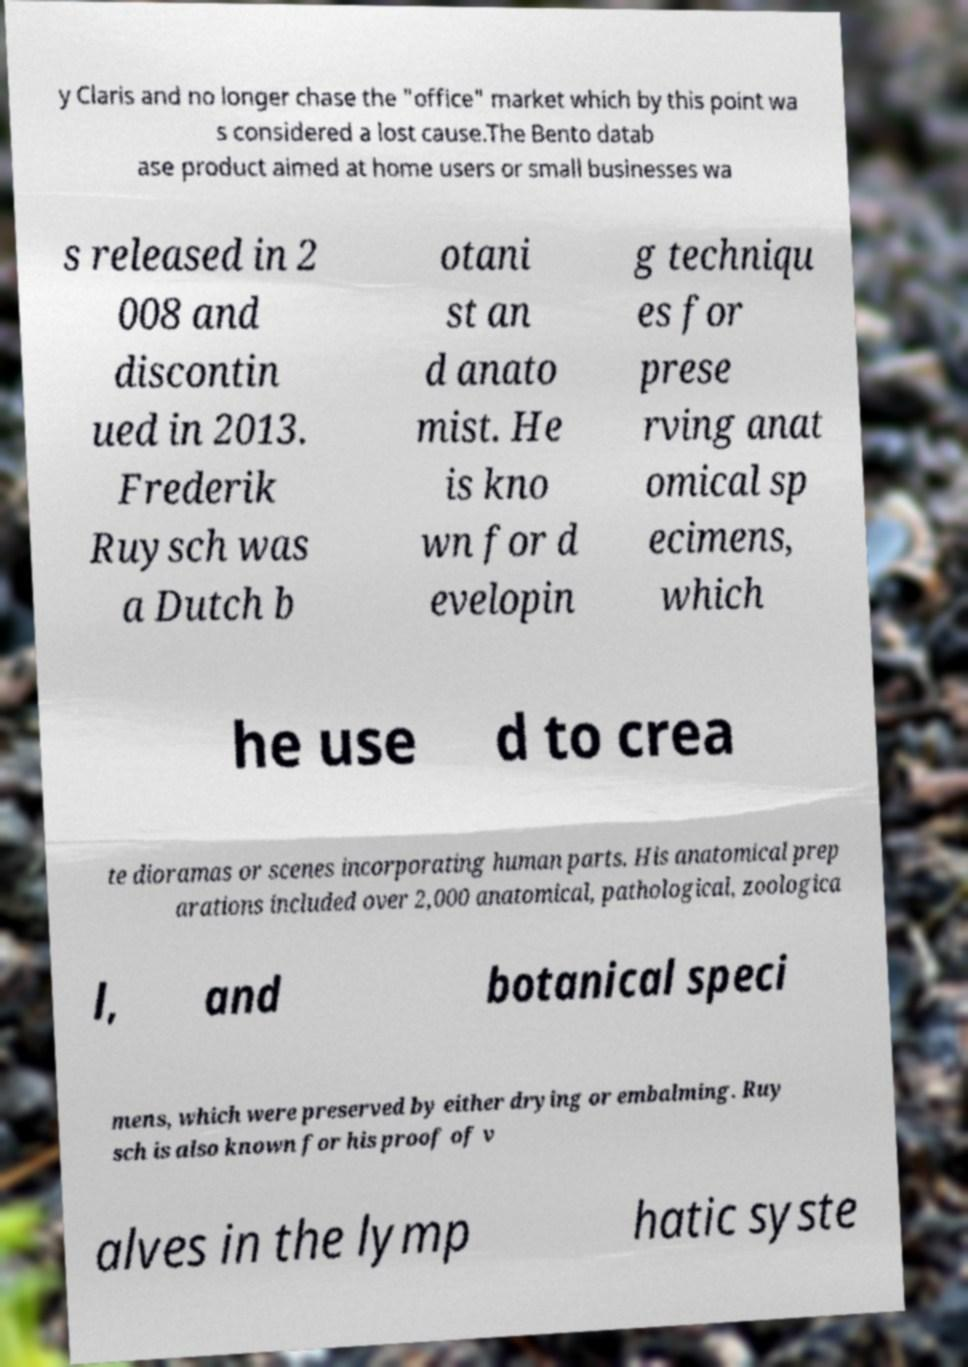Could you assist in decoding the text presented in this image and type it out clearly? y Claris and no longer chase the "office" market which by this point wa s considered a lost cause.The Bento datab ase product aimed at home users or small businesses wa s released in 2 008 and discontin ued in 2013. Frederik Ruysch was a Dutch b otani st an d anato mist. He is kno wn for d evelopin g techniqu es for prese rving anat omical sp ecimens, which he use d to crea te dioramas or scenes incorporating human parts. His anatomical prep arations included over 2,000 anatomical, pathological, zoologica l, and botanical speci mens, which were preserved by either drying or embalming. Ruy sch is also known for his proof of v alves in the lymp hatic syste 